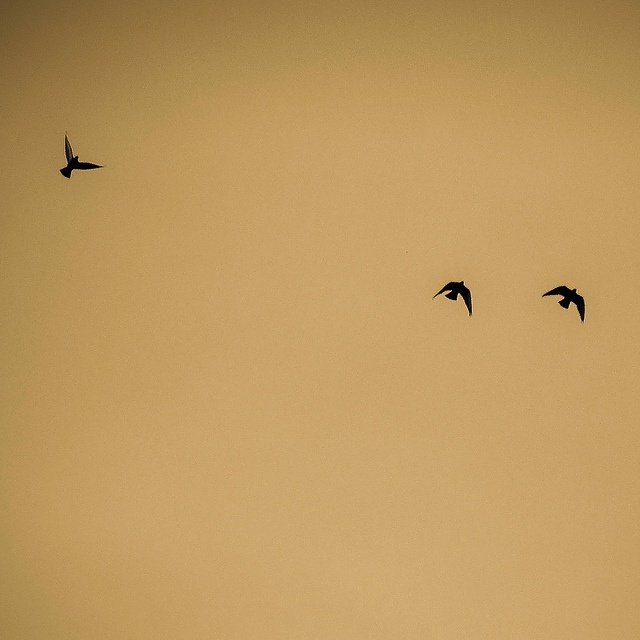Describe the objects in this image and their specific colors. I can see bird in olive, black, and tan tones, bird in olive, black, tan, and gray tones, and bird in olive, black, and gray tones in this image. 